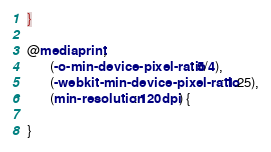Convert code to text. <code><loc_0><loc_0><loc_500><loc_500><_CSS_>
}

@media print,
       (-o-min-device-pixel-ratio: 5/4),
       (-webkit-min-device-pixel-ratio: 1.25),
       (min-resolution: 120dpi) {

}
</code> 